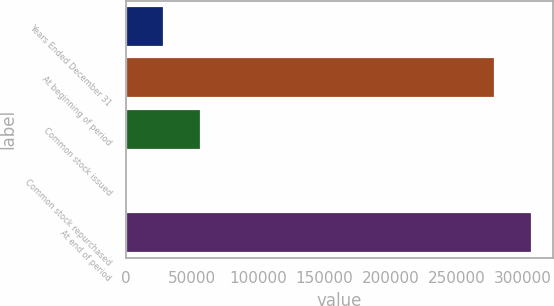Convert chart. <chart><loc_0><loc_0><loc_500><loc_500><bar_chart><fcel>Years Ended December 31<fcel>At beginning of period<fcel>Common stock issued<fcel>Common stock repurchased<fcel>At end of period<nl><fcel>28450<fcel>279206<fcel>56583<fcel>317<fcel>307339<nl></chart> 